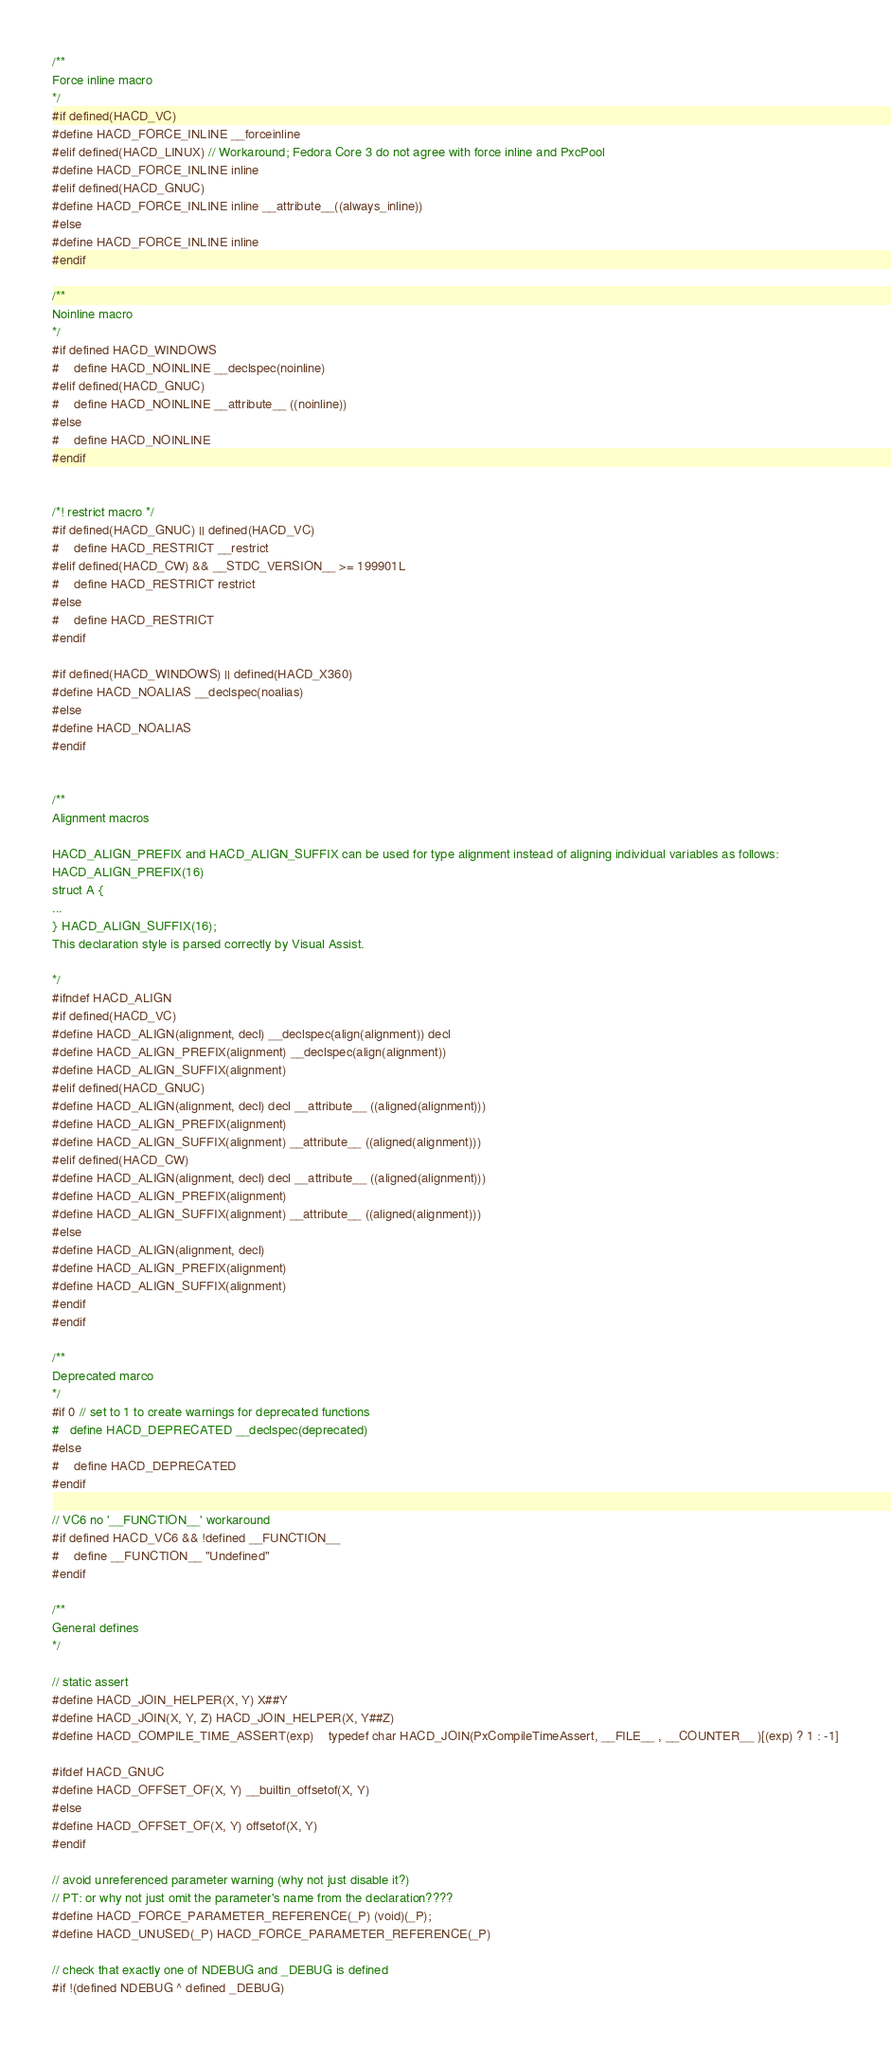<code> <loc_0><loc_0><loc_500><loc_500><_C_>/**
Force inline macro
*/
#if defined(HACD_VC)
#define HACD_FORCE_INLINE __forceinline
#elif defined(HACD_LINUX) // Workaround; Fedora Core 3 do not agree with force inline and PxcPool
#define HACD_FORCE_INLINE inline
#elif defined(HACD_GNUC)
#define HACD_FORCE_INLINE inline __attribute__((always_inline))
#else
#define HACD_FORCE_INLINE inline
#endif

/**
Noinline macro
*/
#if defined HACD_WINDOWS
#	define HACD_NOINLINE __declspec(noinline)
#elif defined(HACD_GNUC)
#	define HACD_NOINLINE __attribute__ ((noinline))
#else
#	define HACD_NOINLINE 
#endif


/*! restrict macro */
#if defined(HACD_GNUC) || defined(HACD_VC)
#	define HACD_RESTRICT __restrict
#elif defined(HACD_CW) && __STDC_VERSION__ >= 199901L
#	define HACD_RESTRICT restrict
#else
#	define HACD_RESTRICT
#endif

#if defined(HACD_WINDOWS) || defined(HACD_X360)
#define HACD_NOALIAS __declspec(noalias)
#else
#define HACD_NOALIAS
#endif


/**
Alignment macros

HACD_ALIGN_PREFIX and HACD_ALIGN_SUFFIX can be used for type alignment instead of aligning individual variables as follows:
HACD_ALIGN_PREFIX(16)
struct A {
...
} HACD_ALIGN_SUFFIX(16);
This declaration style is parsed correctly by Visual Assist.

*/
#ifndef HACD_ALIGN
#if defined(HACD_VC)
#define HACD_ALIGN(alignment, decl) __declspec(align(alignment)) decl
#define HACD_ALIGN_PREFIX(alignment) __declspec(align(alignment))
#define HACD_ALIGN_SUFFIX(alignment)
#elif defined(HACD_GNUC)
#define HACD_ALIGN(alignment, decl) decl __attribute__ ((aligned(alignment)))
#define HACD_ALIGN_PREFIX(alignment)
#define HACD_ALIGN_SUFFIX(alignment) __attribute__ ((aligned(alignment)))
#elif defined(HACD_CW)
#define HACD_ALIGN(alignment, decl) decl __attribute__ ((aligned(alignment)))
#define HACD_ALIGN_PREFIX(alignment)
#define HACD_ALIGN_SUFFIX(alignment) __attribute__ ((aligned(alignment)))
#else
#define HACD_ALIGN(alignment, decl)
#define HACD_ALIGN_PREFIX(alignment)
#define HACD_ALIGN_SUFFIX(alignment)
#endif
#endif

/**
Deprecated marco
*/
#if 0 // set to 1 to create warnings for deprecated functions
#	define HACD_DEPRECATED __declspec(deprecated)
#else 
#	define HACD_DEPRECATED
#endif

// VC6 no '__FUNCTION__' workaround
#if defined HACD_VC6 && !defined __FUNCTION__
#	define __FUNCTION__	"Undefined"
#endif

/**
General defines
*/

// static assert
#define HACD_JOIN_HELPER(X, Y) X##Y
#define HACD_JOIN(X, Y, Z) HACD_JOIN_HELPER(X, Y##Z)
#define HACD_COMPILE_TIME_ASSERT(exp)	typedef char HACD_JOIN(PxCompileTimeAssert, __FILE__ , __COUNTER__ )[(exp) ? 1 : -1]

#ifdef HACD_GNUC
#define HACD_OFFSET_OF(X, Y) __builtin_offsetof(X, Y)
#else
#define HACD_OFFSET_OF(X, Y) offsetof(X, Y)
#endif

// avoid unreferenced parameter warning (why not just disable it?)
// PT: or why not just omit the parameter's name from the declaration????
#define HACD_FORCE_PARAMETER_REFERENCE(_P) (void)(_P);
#define HACD_UNUSED(_P) HACD_FORCE_PARAMETER_REFERENCE(_P)

// check that exactly one of NDEBUG and _DEBUG is defined
#if !(defined NDEBUG ^ defined _DEBUG)</code> 